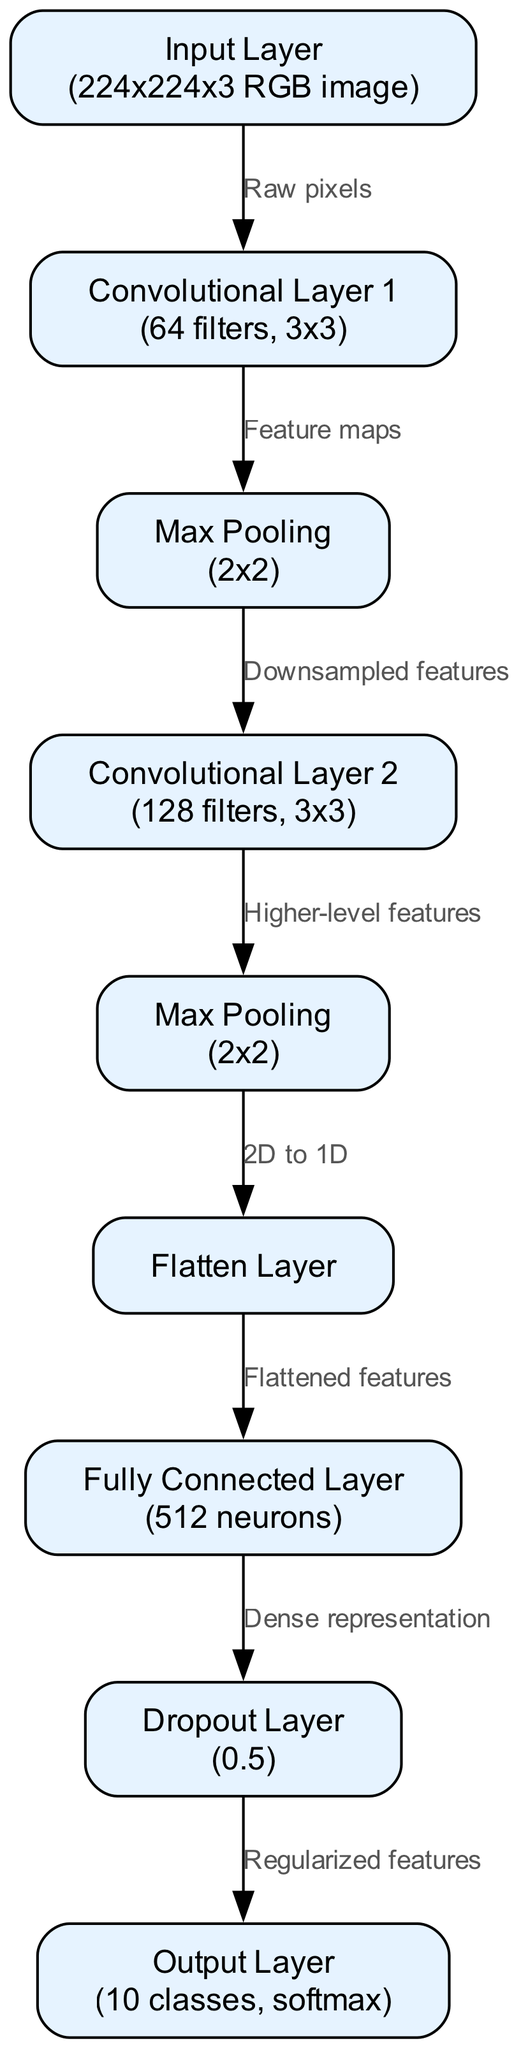What is the size of the input layer? The input layer is labeled as "Input Layer (224x224x3 RGB image)", indicating that the size of the input is 224 by 224 pixels with 3 color channels (RGB).
Answer: 224x224x3 RGB image How many filters are used in Convolutional Layer 1? Convolutional Layer 1 is labeled "Convolutional Layer 1 (64 filters, 3x3)", which means it has 64 filters in that layer.
Answer: 64 filters What type of layer follows the first max pooling layer? The first max pooling layer is labeled as "Max Pooling (2x2)", and the next layer indicated in the diagram is "Convolutional Layer 2".
Answer: Convolutional Layer 2 How many neurons are in the fully connected layer? The fully connected layer is labeled "Fully Connected Layer (512 neurons)", which specifies that it has 512 neurons.
Answer: 512 neurons What does the dropout layer do? The dropout layer is labeled as "Dropout Layer (0.5)", implying that it randomly drops 50% of the neurons during training to reduce overfitting.
Answer: Regularized features Which layer comes before the output layer? The output layer is labeled "Output Layer (10 classes, softmax)" and is preceded by the "Dropout Layer".
Answer: Dropout Layer What transformation occurs between the max pooling layer 2 and the flatten layer? The edge connecting "Max Pooling (2x2)" and "Flatten Layer" indicates a transformation labeled "2D to 1D", meaning the 2D features are being flattened into a 1D array.
Answer: 2D to 1D What is the function of the output layer? The output layer is labeled "Output Layer (10 classes, softmax)", which indicates that its function is to classify the input into one of 10 classes using the softmax function.
Answer: Classify into 10 classes 